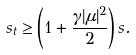<formula> <loc_0><loc_0><loc_500><loc_500>s _ { t } \geq \left ( 1 + \frac { \gamma | \mu | ^ { 2 } } { 2 } \right ) s .</formula> 